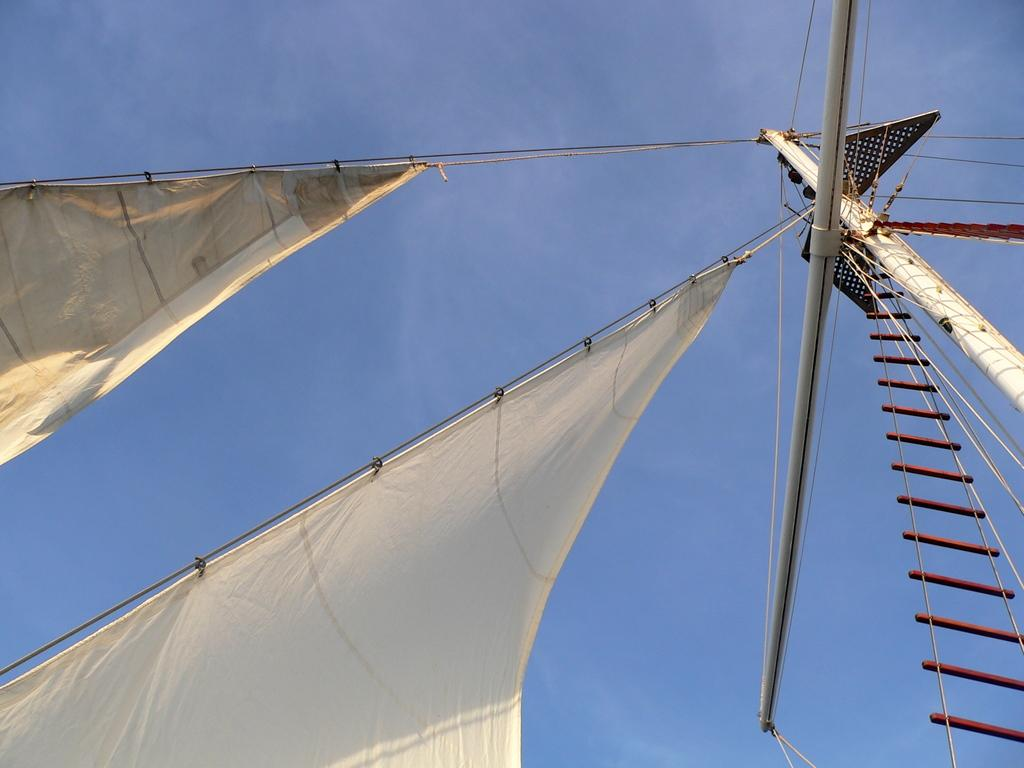What can be seen in the image that is related to sailing? There are sails in the image. What object is present in the image that can be used for climbing or accessing higher areas? There is a ladder in the image. What type of structural elements are visible in the image? There are rods in the image. What can be seen in the background of the image? The sky is visible in the background of the image. What is the color of the sky in the image? The sky is blue in color. Can you tell me how many roses are depicted on the sails in the image? There are no roses present in the image; it features sails, a ladder, and rods. Is there a yam being used as a skate in the image? There is no yam or skate present in the image. 